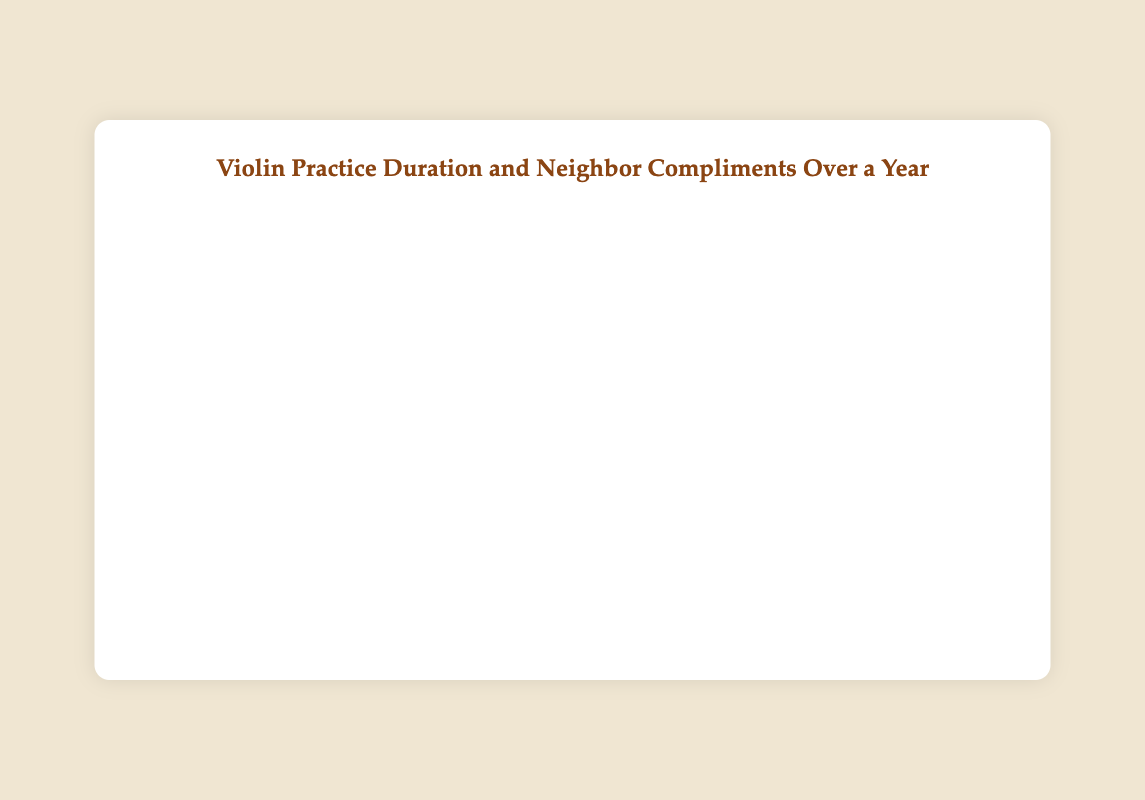When was the peak daily practice duration recorded? The peak daily practice duration can be seen by looking at the highest point on the 'Daily Practice Duration' line. The highest value is 95 minutes, which appears to have been recorded on April 22, 2022.
Answer: April 22, 2022 How many times did the neighbor compliments reach the maximum value of 5? To find this, we need to count the number of points on the 'Neighbor Compliments' line that reach the maximum value of 5. This happened 5 times on February 11, June 30, August 18, October 20, and December 22, 2022.
Answer: 5 times On which date did the neighbor compliments increase the most compared to the previous week? To determine this, we should identify the point with the steepest upward slope in the 'Neighbor Compliments' line. The biggest jump seems to be from January 21 to January 28, where compliments increased from 1 to 4 (an increase of 3).
Answer: January 28, 2022 What was the average daily practice duration in February 2022? Adding up the practice durations for February (50, 90, 60, 40) and dividing by 4, we get (50 + 90 + 60 + 40) / 4 = 240 / 4 = 60 minutes on average.
Answer: 60 minutes Compare the neighbor compliments on February 11 and August 18. Which is higher, and by how much? The neighbor compliments on February 11 were 5, and on August 18, they were also 5. The difference is 0, meaning they are equal.
Answer: Equal, by 0 On which date did the practice duration hit 85 minutes, and how many neighbor compliments corresponded with this duration? Referring to the 'Daily Practice Duration' line at 85 minutes, we see this occurred on January 28, August 11, October 13, and December 15. On each of these dates, neighbor compliments were 4.
Answer: January 28, August 11, October 13, December 15; compliments: 4 What is the minimum practice duration recorded, and how many neighbor compliments were received on that day? The minimum practice duration is 30 minutes, recorded on January 21, 2022. On this day, 1 neighbor compliment was received.
Answer: January 21, 2022; compliments: 1 Is there a correlation between the length of practice and neighbor compliments? Provide an example. Yes, a general trend suggests that longer practice durations tend to correlate with more compliments. For instance, on June 30, with 90 minutes of practice, 5 compliments were received, and similarly on December 22.
Answer: Yes, longer practice correlates with more compliments During which month was the average neighbor compliment the highest? To find the month with the highest average compliments, we calculate the average neighbor compliments for each month. It appears that February had the highest average, with (2 + 5 + 3 + 2) / 4 = 3 compliments on average.
Answer: February 2022 